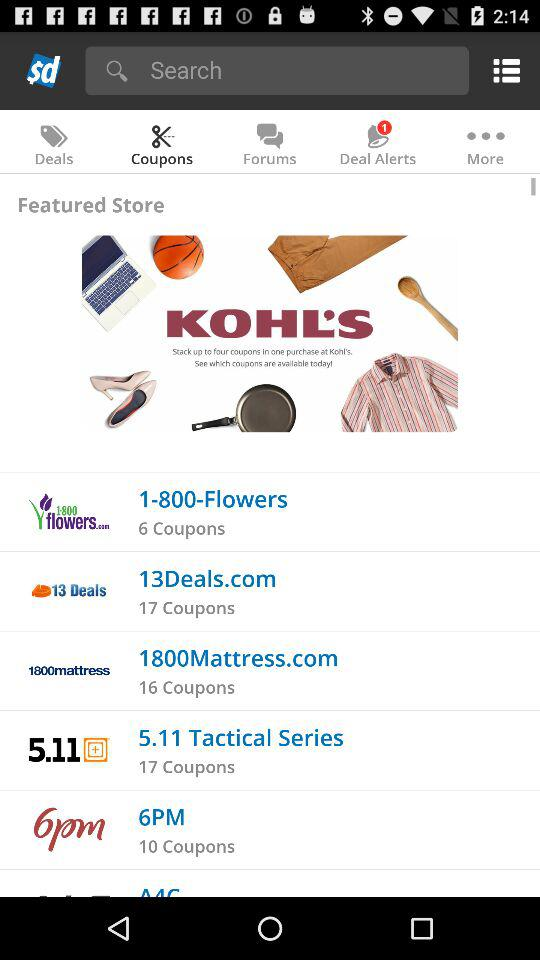What is the selected tab? The selected tab is "Coupons". 